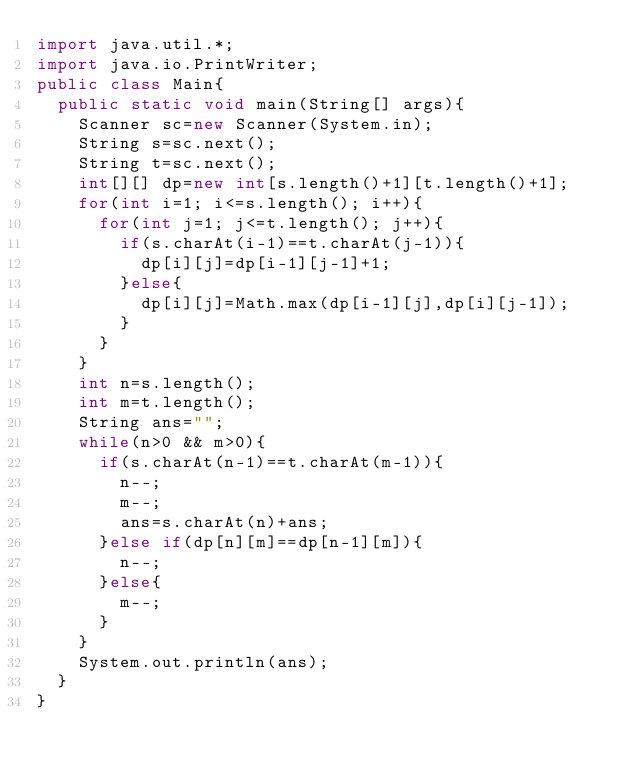<code> <loc_0><loc_0><loc_500><loc_500><_Java_>import java.util.*;
import java.io.PrintWriter;
public class Main{
	public static void main(String[] args){
		Scanner sc=new Scanner(System.in);
		String s=sc.next();
		String t=sc.next();
		int[][] dp=new int[s.length()+1][t.length()+1];
		for(int i=1; i<=s.length(); i++){
			for(int j=1; j<=t.length(); j++){
				if(s.charAt(i-1)==t.charAt(j-1)){
					dp[i][j]=dp[i-1][j-1]+1;
				}else{
					dp[i][j]=Math.max(dp[i-1][j],dp[i][j-1]);
				}
			}
		}
		int n=s.length();
		int m=t.length();
		String ans="";
		while(n>0 && m>0){
			if(s.charAt(n-1)==t.charAt(m-1)){
				n--;
				m--;
				ans=s.charAt(n)+ans;
			}else if(dp[n][m]==dp[n-1][m]){
				n--;
			}else{
				m--;
			}
		}
		System.out.println(ans);
	}
}
</code> 